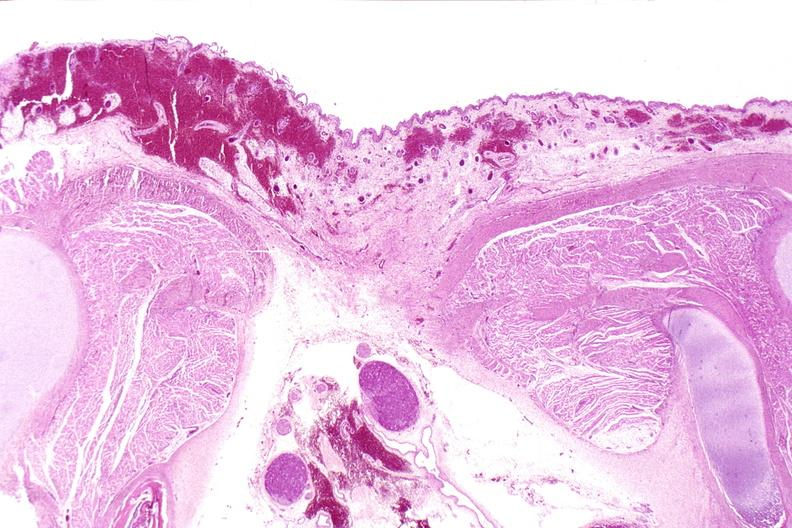does papillary adenoma show neural tube defect, meningomyelocele?
Answer the question using a single word or phrase. No 